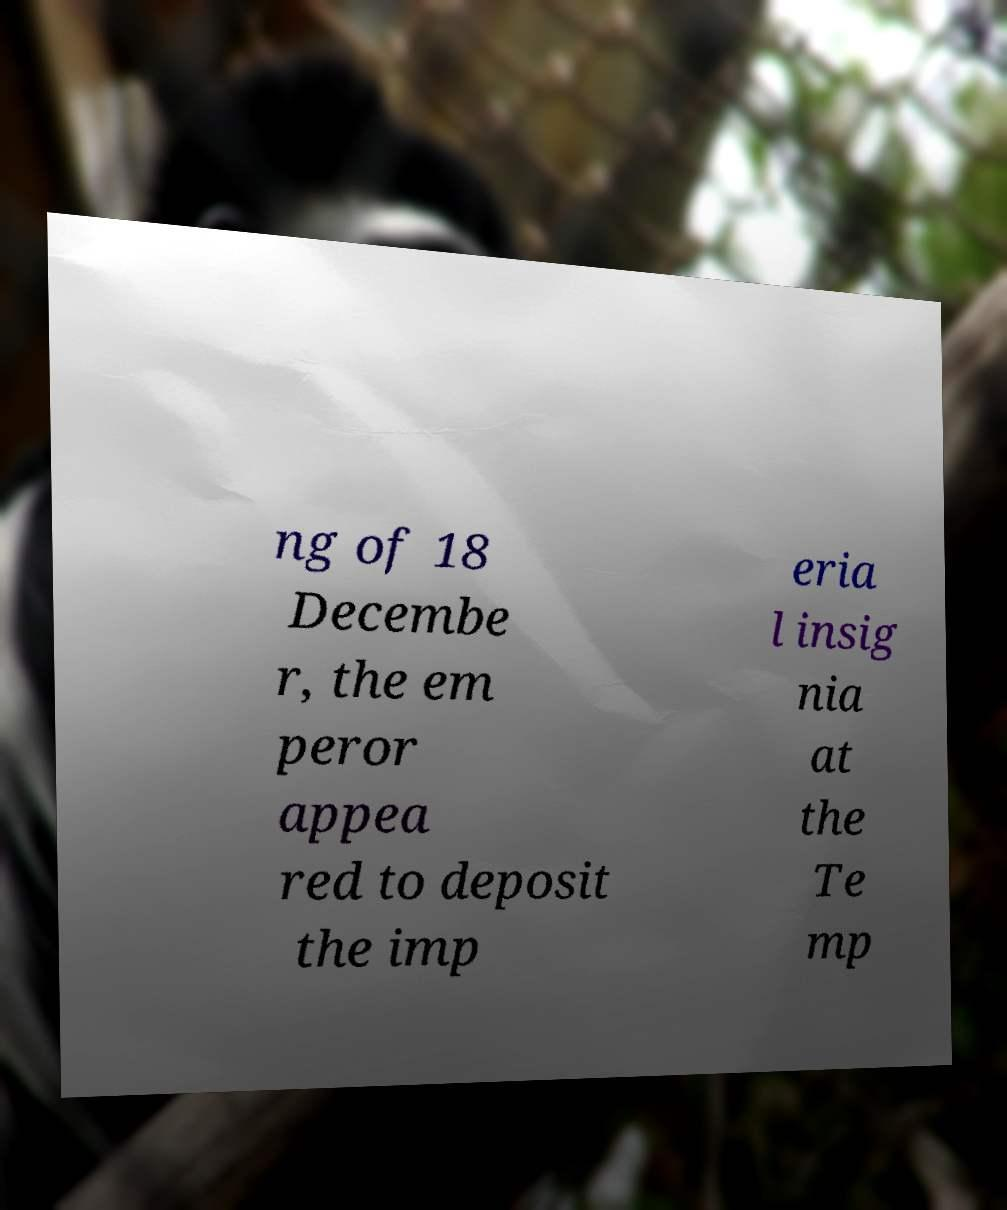What messages or text are displayed in this image? I need them in a readable, typed format. ng of 18 Decembe r, the em peror appea red to deposit the imp eria l insig nia at the Te mp 